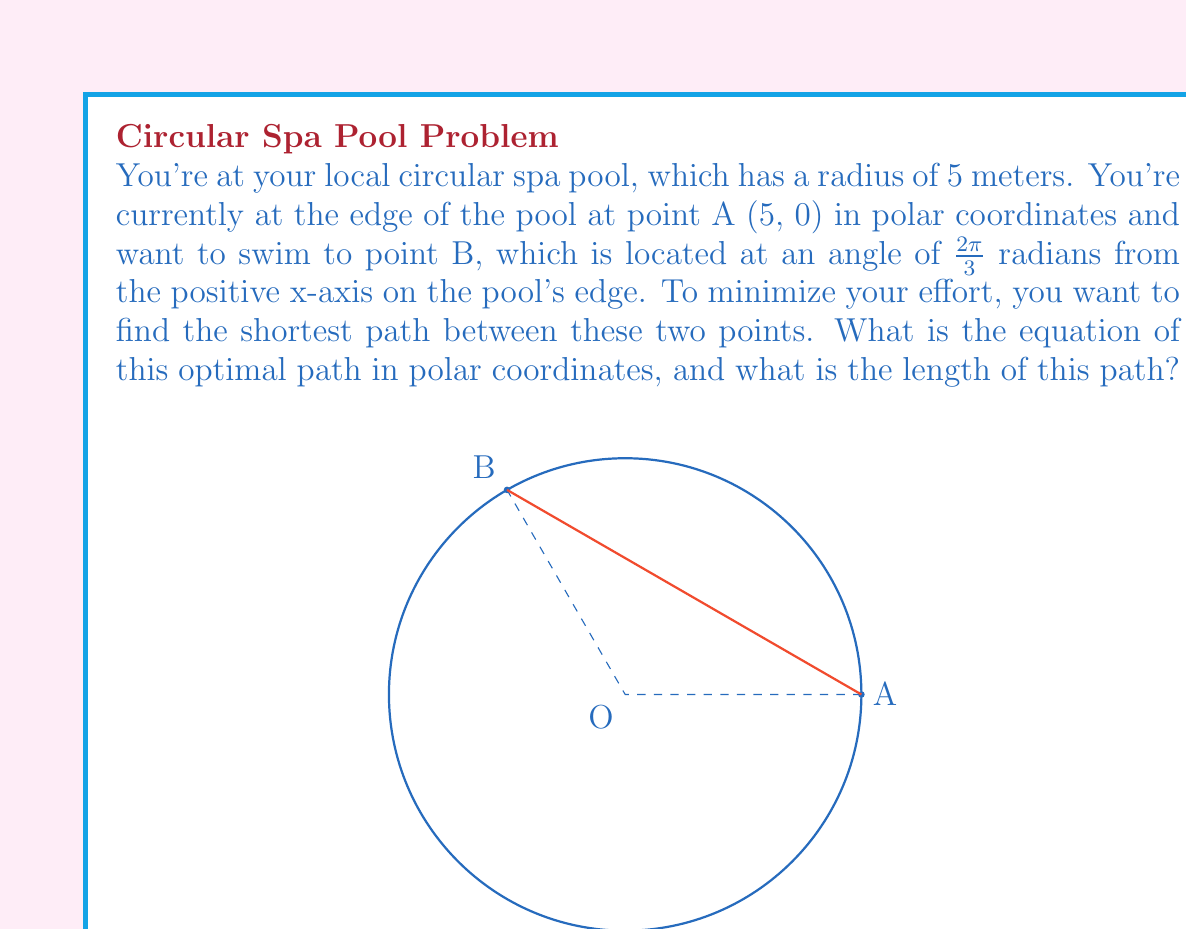Teach me how to tackle this problem. Let's approach this step-by-step:

1) The shortest path between two points on a circle is not the arc, but a straight line (chord) connecting them.

2) In polar coordinates, a straight line that doesn't pass through the origin is given by the equation:

   $$r = \frac{p}{\cos(\theta - \alpha)}$$

   where $p$ is the perpendicular distance from the origin to the line, and $\alpha$ is the angle this perpendicular makes with the positive x-axis.

3) To find $p$ and $\alpha$, we can use the properties of an equilateral triangle:
   - The line from the center to the midpoint of our chord bisects the central angle.
   - This creates a 30-60-90 triangle (since the central angle is $\frac{2\pi}{3} = 120°$).

4) In a 30-60-90 triangle with hypotenuse 5:
   - The shortest side (opposite to 30°) is $5 \cdot \frac{1}{2} = 2.5$
   - The middle side (opposite to 60°) is $5 \cdot \frac{\sqrt{3}}{2} = \frac{5\sqrt{3}}{2}$

5) Therefore, $p = 2.5$ and $\alpha = \frac{\pi}{6}$ (30°)

6) Substituting these into our equation:

   $$r = \frac{2.5}{\cos(\theta - \frac{\pi}{6})}$$

7) To find the length of this path, we can use the distance formula between two points in polar coordinates:

   $$d = \sqrt{r_1^2 + r_2^2 - 2r_1r_2\cos(\theta_2 - \theta_1)}$$

   where $(r_1, \theta_1)$ and $(r_2, \theta_2)$ are the polar coordinates of the two points.

8) Here, $r_1 = r_2 = 5$, and $\theta_2 - \theta_1 = \frac{2\pi}{3}$

9) Substituting:

   $$d = \sqrt{5^2 + 5^2 - 2(5)(5)\cos(\frac{2\pi}{3})}$$
   $$= \sqrt{50 - 50(-\frac{1}{2})}$$
   $$= \sqrt{75} = 5\sqrt{3}$$
Answer: The equation of the optimal path in polar coordinates is $r = \frac{2.5}{\cos(\theta - \frac{\pi}{6})}$, and the length of this path is $5\sqrt{3}$ meters. 